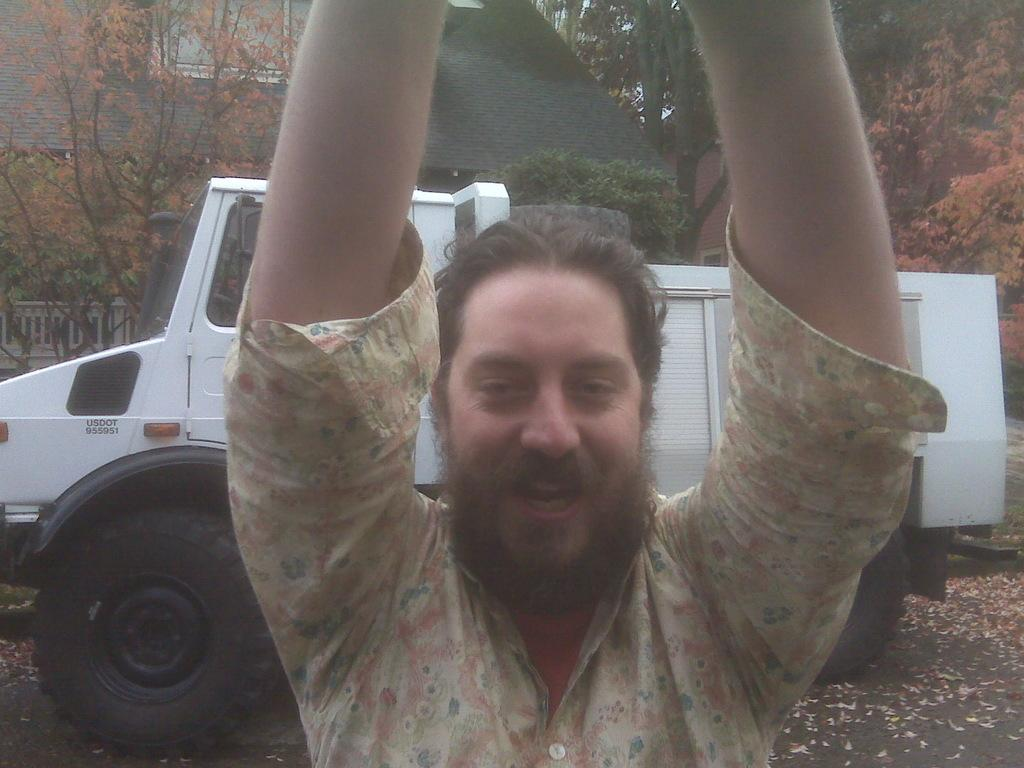What is present in the image? There is a person in the image, along with a vehicle on the road, a fence on the left side, trees, and buildings in the background. Can you describe the person in the image? The provided facts do not give any details about the person's appearance or clothing. What type of vehicle is on the road in the image? The facts do not specify the type of vehicle on the road. What can be seen in the background of the image? In the background, there are trees and buildings. How many ladybugs are crawling on the person in the image? There is no mention of ladybugs in the image, so we cannot determine their presence or quantity. What does the person's son think about the vehicle on the road? The provided facts do not mention a son or any opinions about the vehicle. 